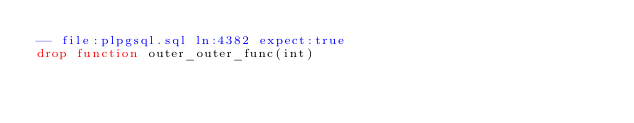Convert code to text. <code><loc_0><loc_0><loc_500><loc_500><_SQL_>-- file:plpgsql.sql ln:4382 expect:true
drop function outer_outer_func(int)
</code> 